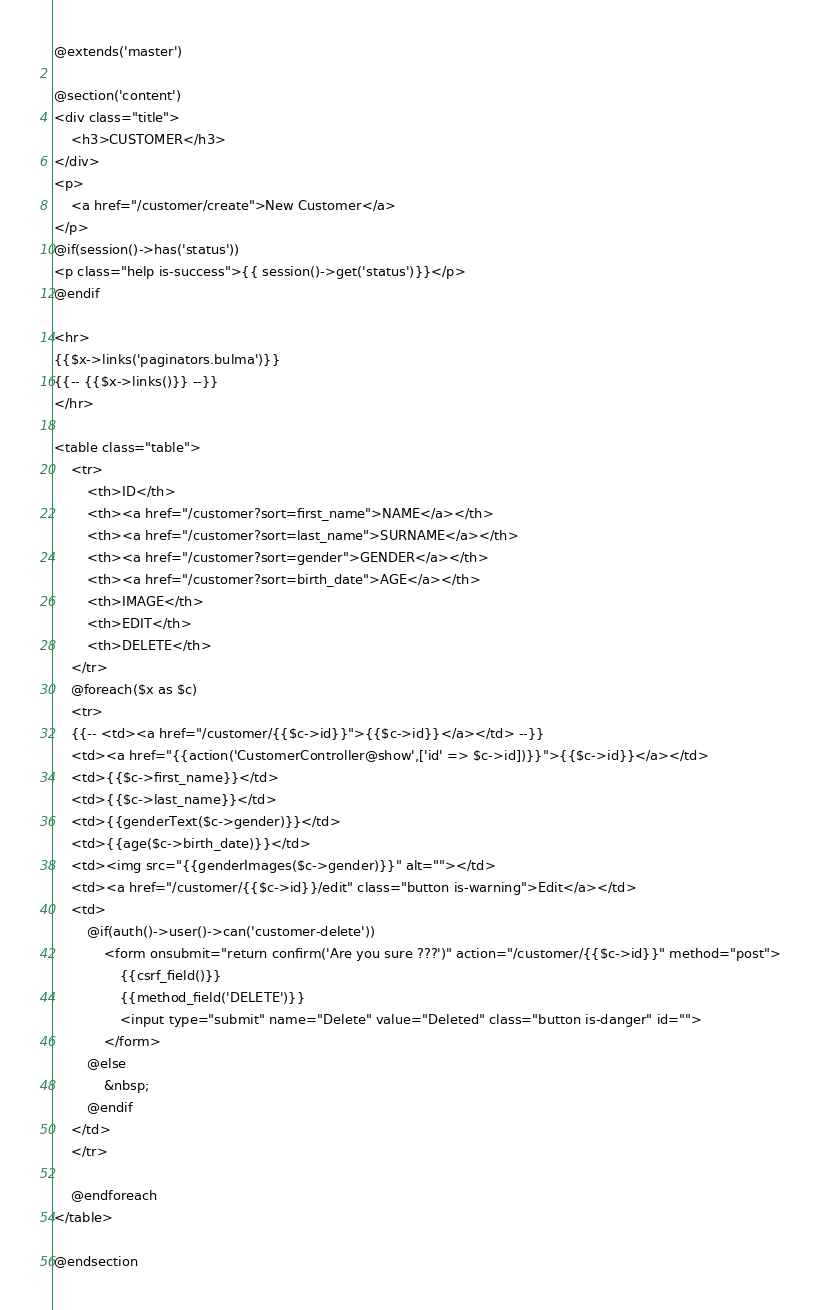<code> <loc_0><loc_0><loc_500><loc_500><_PHP_>@extends('master')

@section('content')
<div class="title">
    <h3>CUSTOMER</h3>   
</div>
<p>
    <a href="/customer/create">New Customer</a>
</p>
@if(session()->has('status'))
<p class="help is-success">{{ session()->get('status')}}</p>
@endif

<hr>
{{$x->links('paginators.bulma')}}
{{-- {{$x->links()}} --}}
</hr>

<table class="table">
    <tr>
        <th>ID</th>
        <th><a href="/customer?sort=first_name">NAME</a></th>
        <th><a href="/customer?sort=last_name">SURNAME</a></th>
        <th><a href="/customer?sort=gender">GENDER</a></th>
        <th><a href="/customer?sort=birth_date">AGE</a></th>
        <th>IMAGE</th>
        <th>EDIT</th>
        <th>DELETE</th>
    </tr>
    @foreach($x as $c)
    <tr>
    {{-- <td><a href="/customer/{{$c->id}}">{{$c->id}}</a></td> --}}
    <td><a href="{{action('CustomerController@show',['id' => $c->id])}}">{{$c->id}}</a></td>
    <td>{{$c->first_name}}</td>
    <td>{{$c->last_name}}</td>
    <td>{{genderText($c->gender)}}</td>
    <td>{{age($c->birth_date)}}</td>
    <td><img src="{{genderImages($c->gender)}}" alt=""></td>
    <td><a href="/customer/{{$c->id}}/edit" class="button is-warning">Edit</a></td>
    <td>
        @if(auth()->user()->can('customer-delete'))
            <form onsubmit="return confirm('Are you sure ???')" action="/customer/{{$c->id}}" method="post">
                {{csrf_field()}}
                {{method_field('DELETE')}}
                <input type="submit" name="Delete" value="Deleted" class="button is-danger" id="">
            </form>
        @else
            &nbsp;
        @endif
    </td>
    </tr>
    
    @endforeach
</table>

@endsection</code> 